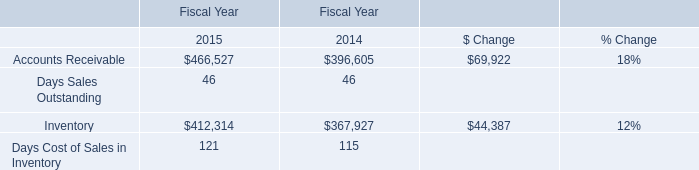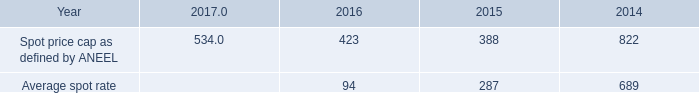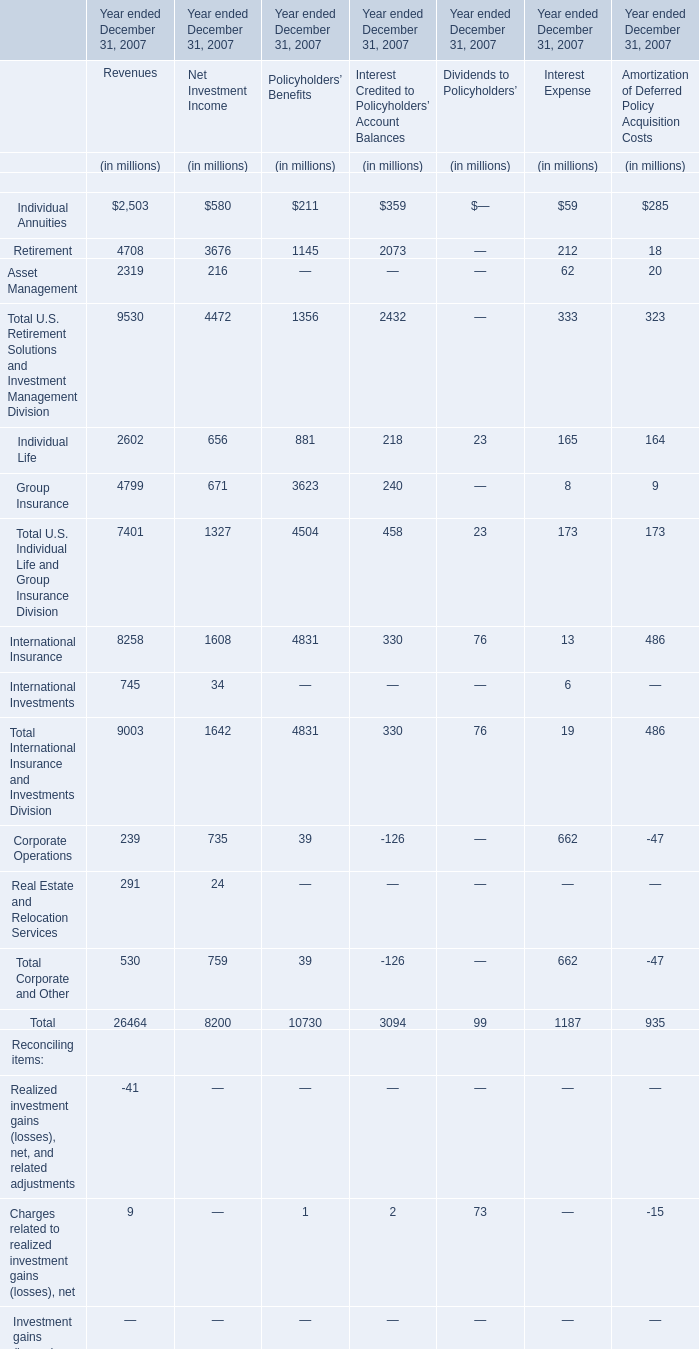What is the proportion of all elements that are greater than 4000 to the total amount of elements, for Revenues? 
Computations: ((((4708 + 4799) + 8258) + 7981) / 34377)
Answer: 0.74893. 